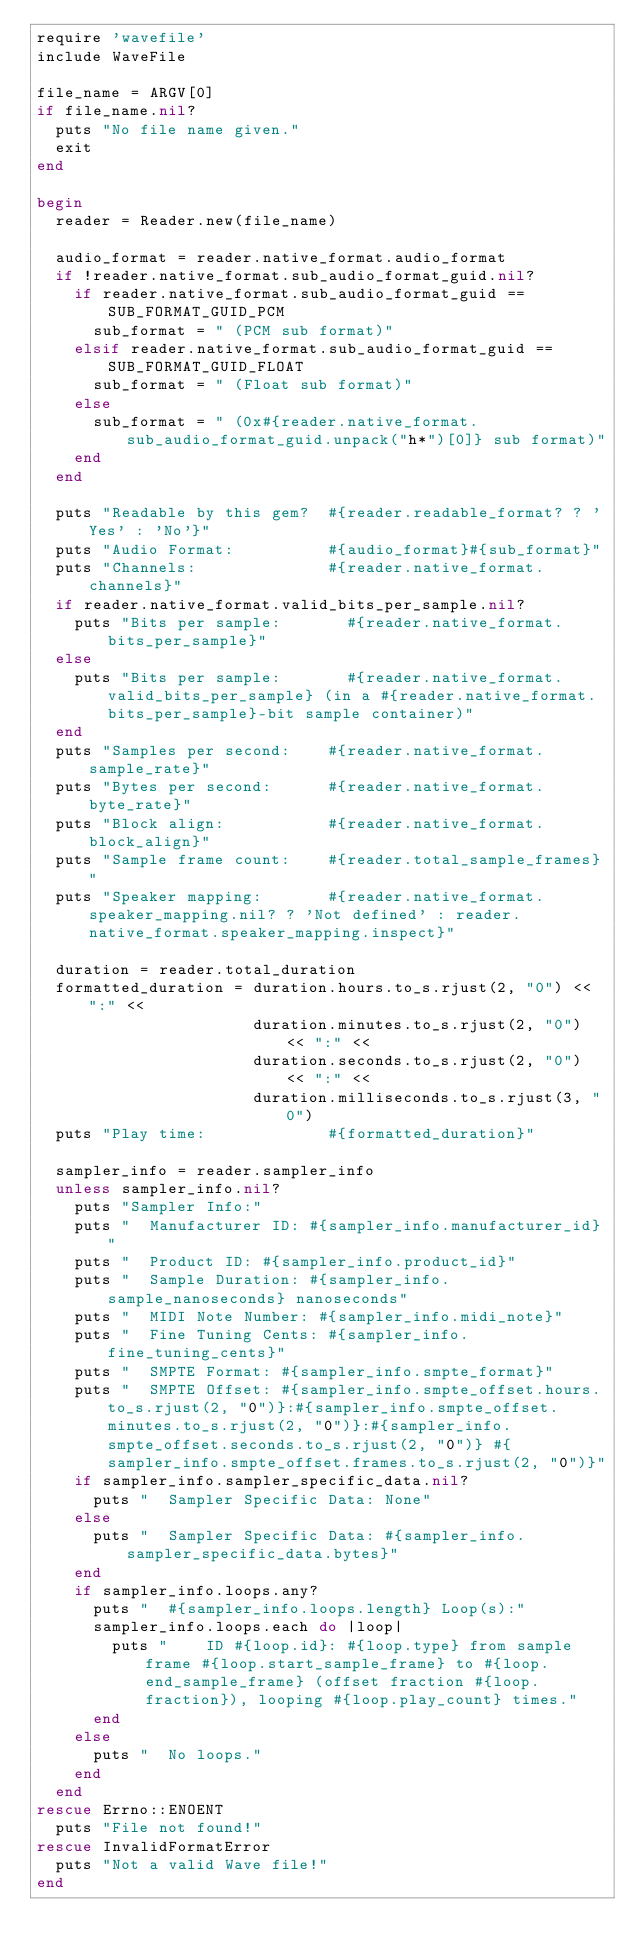<code> <loc_0><loc_0><loc_500><loc_500><_Ruby_>require 'wavefile'
include WaveFile

file_name = ARGV[0]
if file_name.nil?
  puts "No file name given."
  exit
end

begin
  reader = Reader.new(file_name)

  audio_format = reader.native_format.audio_format
  if !reader.native_format.sub_audio_format_guid.nil?
    if reader.native_format.sub_audio_format_guid == SUB_FORMAT_GUID_PCM
      sub_format = " (PCM sub format)"
    elsif reader.native_format.sub_audio_format_guid == SUB_FORMAT_GUID_FLOAT
      sub_format = " (Float sub format)"
    else
      sub_format = " (0x#{reader.native_format.sub_audio_format_guid.unpack("h*")[0]} sub format)"
    end
  end

  puts "Readable by this gem?  #{reader.readable_format? ? 'Yes' : 'No'}"
  puts "Audio Format:          #{audio_format}#{sub_format}"
  puts "Channels:              #{reader.native_format.channels}"
  if reader.native_format.valid_bits_per_sample.nil?
    puts "Bits per sample:       #{reader.native_format.bits_per_sample}"
  else
    puts "Bits per sample:       #{reader.native_format.valid_bits_per_sample} (in a #{reader.native_format.bits_per_sample}-bit sample container)"
  end
  puts "Samples per second:    #{reader.native_format.sample_rate}"
  puts "Bytes per second:      #{reader.native_format.byte_rate}"
  puts "Block align:           #{reader.native_format.block_align}"
  puts "Sample frame count:    #{reader.total_sample_frames}"
  puts "Speaker mapping:       #{reader.native_format.speaker_mapping.nil? ? 'Not defined' : reader.native_format.speaker_mapping.inspect}"

  duration = reader.total_duration
  formatted_duration = duration.hours.to_s.rjust(2, "0") << ":" <<
                       duration.minutes.to_s.rjust(2, "0") << ":" <<
                       duration.seconds.to_s.rjust(2, "0") << ":" <<
                       duration.milliseconds.to_s.rjust(3, "0")
  puts "Play time:             #{formatted_duration}"

  sampler_info = reader.sampler_info
  unless sampler_info.nil?
    puts "Sampler Info:"
    puts "  Manufacturer ID: #{sampler_info.manufacturer_id}"
    puts "  Product ID: #{sampler_info.product_id}"
    puts "  Sample Duration: #{sampler_info.sample_nanoseconds} nanoseconds"
    puts "  MIDI Note Number: #{sampler_info.midi_note}"
    puts "  Fine Tuning Cents: #{sampler_info.fine_tuning_cents}"
    puts "  SMPTE Format: #{sampler_info.smpte_format}"
    puts "  SMPTE Offset: #{sampler_info.smpte_offset.hours.to_s.rjust(2, "0")}:#{sampler_info.smpte_offset.minutes.to_s.rjust(2, "0")}:#{sampler_info.smpte_offset.seconds.to_s.rjust(2, "0")} #{sampler_info.smpte_offset.frames.to_s.rjust(2, "0")}"
    if sampler_info.sampler_specific_data.nil?
      puts "  Sampler Specific Data: None"
    else
      puts "  Sampler Specific Data: #{sampler_info.sampler_specific_data.bytes}"
    end
    if sampler_info.loops.any?
      puts "  #{sampler_info.loops.length} Loop(s):"
      sampler_info.loops.each do |loop|
        puts "    ID #{loop.id}: #{loop.type} from sample frame #{loop.start_sample_frame} to #{loop.end_sample_frame} (offset fraction #{loop.fraction}), looping #{loop.play_count} times."
      end
    else
      puts "  No loops."
    end
  end
rescue Errno::ENOENT
  puts "File not found!"
rescue InvalidFormatError
  puts "Not a valid Wave file!"
end
</code> 